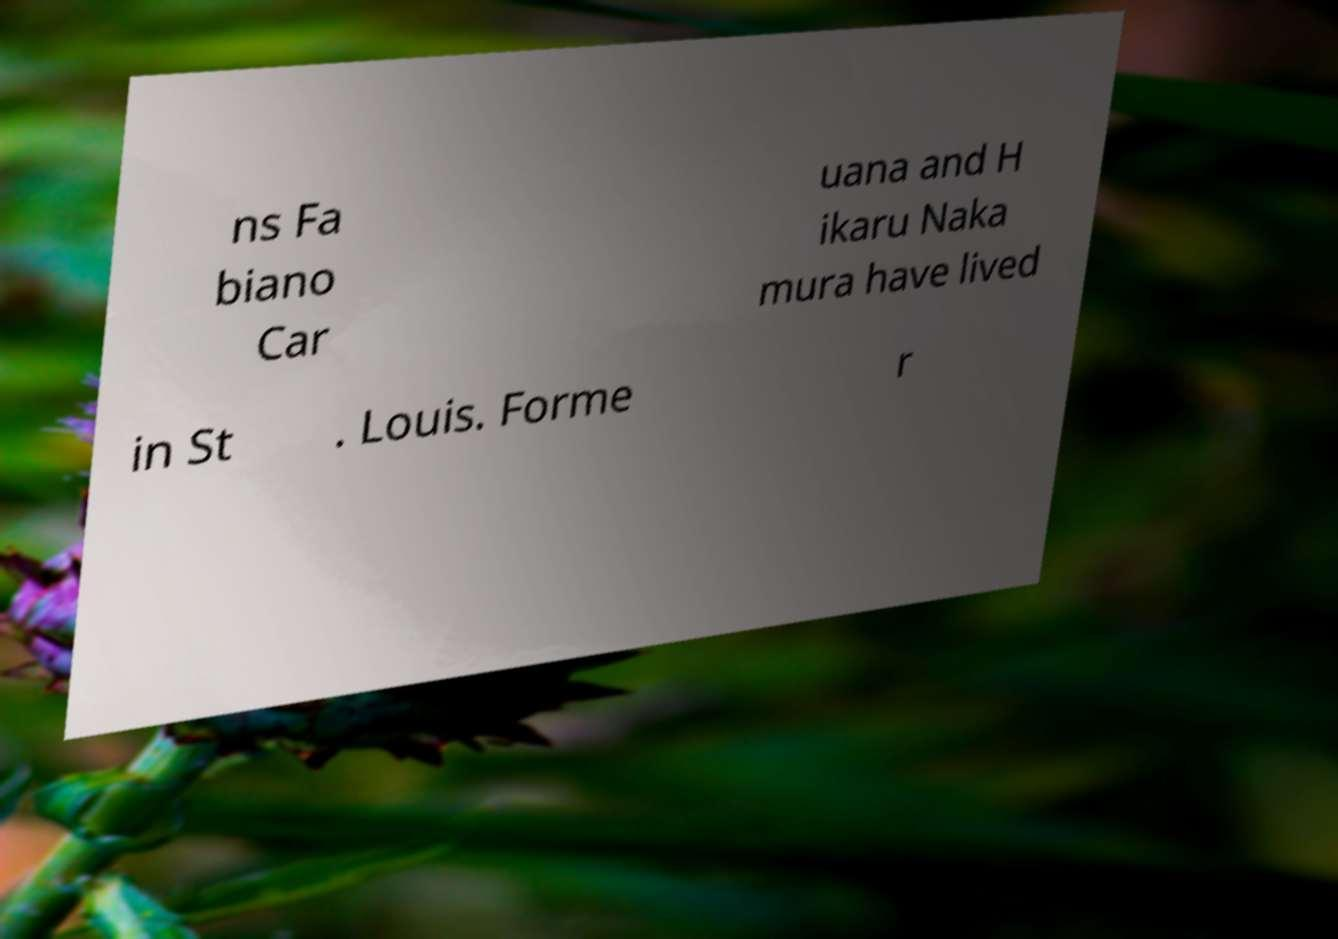Could you extract and type out the text from this image? ns Fa biano Car uana and H ikaru Naka mura have lived in St . Louis. Forme r 